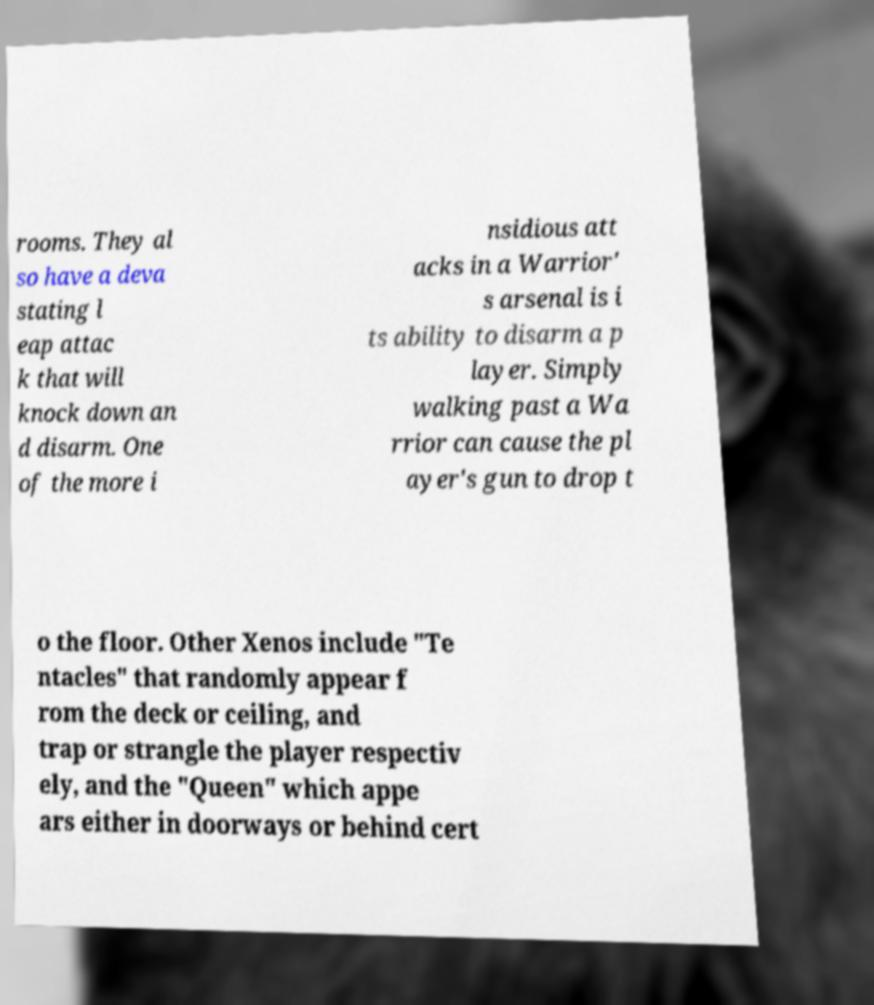Could you extract and type out the text from this image? rooms. They al so have a deva stating l eap attac k that will knock down an d disarm. One of the more i nsidious att acks in a Warrior' s arsenal is i ts ability to disarm a p layer. Simply walking past a Wa rrior can cause the pl ayer's gun to drop t o the floor. Other Xenos include "Te ntacles" that randomly appear f rom the deck or ceiling, and trap or strangle the player respectiv ely, and the "Queen" which appe ars either in doorways or behind cert 